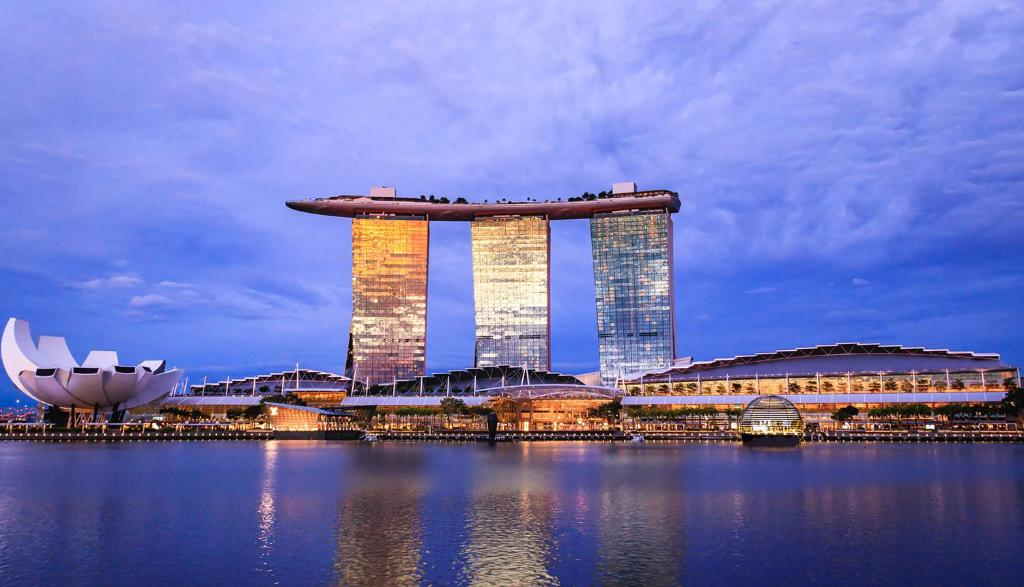Imagine a poetic description of the scene. In azure embrace, the city’s jewels ignite, Towers that kiss the sky with golden light. Reflecting dreams on waters still and wide, 'Neath twilight's whisper, where the heavens collide. A lotus blooms, art and science converge, In this urban symphony, ambitions surge. Peace and innovation, in perfect harmony blend, A tale of tomorrow, where stories never end. Conceive a short, realistic scenario of the image. It's a serene evening at Marina Bay Sands. Tourists gather at the SkyPark, sipping cocktails by the infinity pool, as the sun begins to set. The city lights start to twinkle, mirroring on the water below. A couple takes a selfie with the ArtScience Museum in the background, capturing a moment of their honeymoon. Nearby, a businessperson enjoys a quiet dinner, overlooking the vibrant cityscape. Describe a longer, realistic scenario of the image. As twilight descends on Marina Bay Sands, the hotel bustles with activity. Families check into their luxurious rooms, eager to explore the complex. At the SkyPark, a diverse crowd enjoys the infinity pool; some marvel at the panoramic views, while others find solace in the tranquil gardens. Downstairs, the casino hums with anticipation, players hoping for their lucky break. At the ArtScience Museum, visitors are enthralled by a captivating exhibit that merges art and technology. Along the waterfront promenade, couples stroll hand in hand, taking in the stunning reflections on the bay. Dinner cruises set sail, their passengers ready to enjoy world-class cuisine against the backdrop of an illuminated skyline. It’s a night where every corner of Marina Bay Sands offers a new adventure, a testament to its blend of luxury, innovation, and cultural richness. 